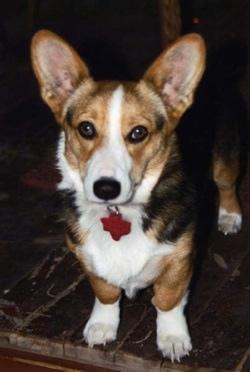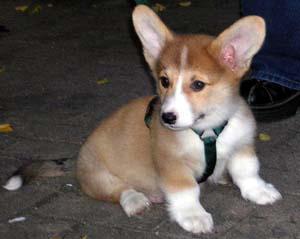The first image is the image on the left, the second image is the image on the right. Evaluate the accuracy of this statement regarding the images: "There are at most two dogs.". Is it true? Answer yes or no. Yes. The first image is the image on the left, the second image is the image on the right. For the images displayed, is the sentence "There are exactly two dogs." factually correct? Answer yes or no. Yes. 